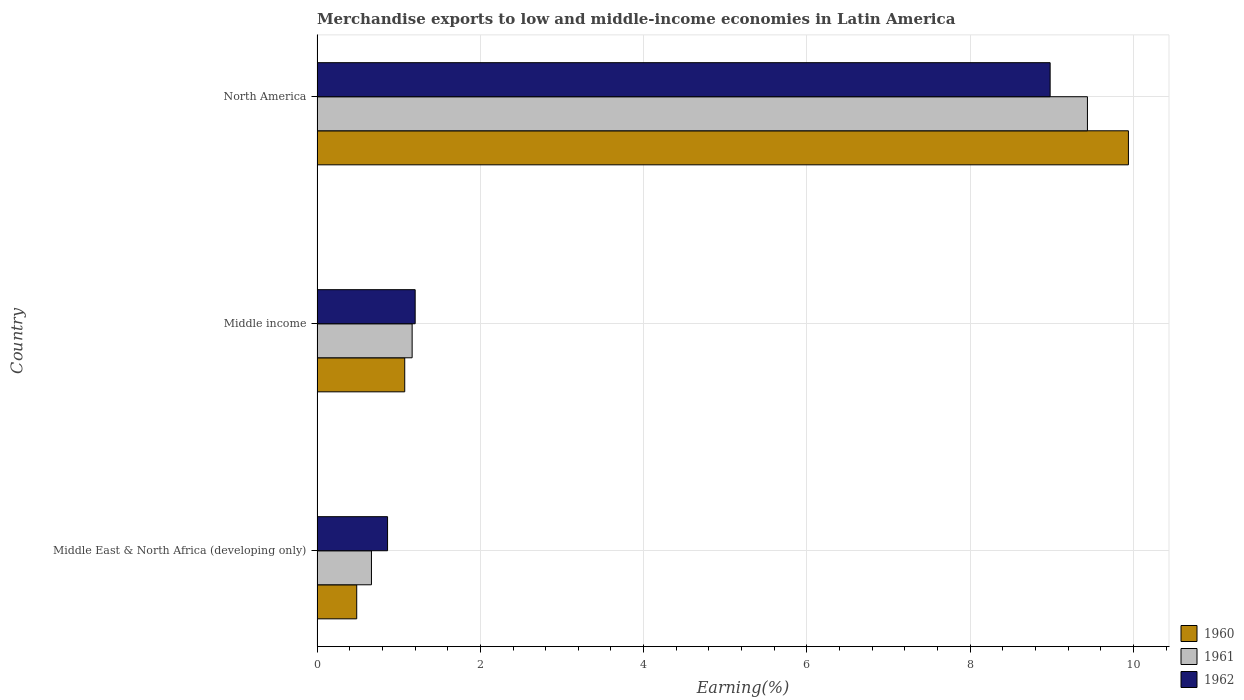How many different coloured bars are there?
Your answer should be very brief. 3. How many groups of bars are there?
Offer a terse response. 3. Are the number of bars per tick equal to the number of legend labels?
Offer a very short reply. Yes. How many bars are there on the 3rd tick from the top?
Keep it short and to the point. 3. What is the label of the 2nd group of bars from the top?
Provide a short and direct response. Middle income. What is the percentage of amount earned from merchandise exports in 1961 in Middle income?
Provide a short and direct response. 1.16. Across all countries, what is the maximum percentage of amount earned from merchandise exports in 1961?
Your answer should be compact. 9.44. Across all countries, what is the minimum percentage of amount earned from merchandise exports in 1962?
Your answer should be very brief. 0.86. In which country was the percentage of amount earned from merchandise exports in 1962 minimum?
Make the answer very short. Middle East & North Africa (developing only). What is the total percentage of amount earned from merchandise exports in 1962 in the graph?
Provide a short and direct response. 11.04. What is the difference between the percentage of amount earned from merchandise exports in 1960 in Middle income and that in North America?
Offer a very short reply. -8.86. What is the difference between the percentage of amount earned from merchandise exports in 1962 in Middle income and the percentage of amount earned from merchandise exports in 1960 in Middle East & North Africa (developing only)?
Keep it short and to the point. 0.72. What is the average percentage of amount earned from merchandise exports in 1961 per country?
Make the answer very short. 3.76. What is the difference between the percentage of amount earned from merchandise exports in 1962 and percentage of amount earned from merchandise exports in 1960 in Middle income?
Provide a succinct answer. 0.13. In how many countries, is the percentage of amount earned from merchandise exports in 1960 greater than 1.6 %?
Offer a very short reply. 1. What is the ratio of the percentage of amount earned from merchandise exports in 1961 in Middle East & North Africa (developing only) to that in Middle income?
Your answer should be compact. 0.57. Is the difference between the percentage of amount earned from merchandise exports in 1962 in Middle income and North America greater than the difference between the percentage of amount earned from merchandise exports in 1960 in Middle income and North America?
Offer a very short reply. Yes. What is the difference between the highest and the second highest percentage of amount earned from merchandise exports in 1960?
Provide a succinct answer. 8.86. What is the difference between the highest and the lowest percentage of amount earned from merchandise exports in 1960?
Make the answer very short. 9.45. What does the 2nd bar from the bottom in North America represents?
Keep it short and to the point. 1961. Is it the case that in every country, the sum of the percentage of amount earned from merchandise exports in 1961 and percentage of amount earned from merchandise exports in 1962 is greater than the percentage of amount earned from merchandise exports in 1960?
Keep it short and to the point. Yes. How many bars are there?
Provide a succinct answer. 9. Are all the bars in the graph horizontal?
Keep it short and to the point. Yes. How many countries are there in the graph?
Make the answer very short. 3. Are the values on the major ticks of X-axis written in scientific E-notation?
Keep it short and to the point. No. Does the graph contain grids?
Give a very brief answer. Yes. What is the title of the graph?
Your response must be concise. Merchandise exports to low and middle-income economies in Latin America. What is the label or title of the X-axis?
Provide a succinct answer. Earning(%). What is the label or title of the Y-axis?
Your answer should be compact. Country. What is the Earning(%) of 1960 in Middle East & North Africa (developing only)?
Ensure brevity in your answer.  0.49. What is the Earning(%) in 1961 in Middle East & North Africa (developing only)?
Offer a terse response. 0.67. What is the Earning(%) of 1962 in Middle East & North Africa (developing only)?
Keep it short and to the point. 0.86. What is the Earning(%) of 1960 in Middle income?
Ensure brevity in your answer.  1.07. What is the Earning(%) of 1961 in Middle income?
Your answer should be very brief. 1.16. What is the Earning(%) in 1962 in Middle income?
Ensure brevity in your answer.  1.2. What is the Earning(%) of 1960 in North America?
Give a very brief answer. 9.94. What is the Earning(%) in 1961 in North America?
Your answer should be compact. 9.44. What is the Earning(%) of 1962 in North America?
Make the answer very short. 8.98. Across all countries, what is the maximum Earning(%) in 1960?
Your answer should be very brief. 9.94. Across all countries, what is the maximum Earning(%) of 1961?
Your response must be concise. 9.44. Across all countries, what is the maximum Earning(%) of 1962?
Your response must be concise. 8.98. Across all countries, what is the minimum Earning(%) of 1960?
Keep it short and to the point. 0.49. Across all countries, what is the minimum Earning(%) of 1961?
Provide a succinct answer. 0.67. Across all countries, what is the minimum Earning(%) of 1962?
Provide a short and direct response. 0.86. What is the total Earning(%) in 1960 in the graph?
Give a very brief answer. 11.5. What is the total Earning(%) of 1961 in the graph?
Keep it short and to the point. 11.27. What is the total Earning(%) in 1962 in the graph?
Provide a succinct answer. 11.04. What is the difference between the Earning(%) of 1960 in Middle East & North Africa (developing only) and that in Middle income?
Keep it short and to the point. -0.59. What is the difference between the Earning(%) of 1961 in Middle East & North Africa (developing only) and that in Middle income?
Provide a succinct answer. -0.5. What is the difference between the Earning(%) of 1962 in Middle East & North Africa (developing only) and that in Middle income?
Your answer should be very brief. -0.34. What is the difference between the Earning(%) of 1960 in Middle East & North Africa (developing only) and that in North America?
Your response must be concise. -9.45. What is the difference between the Earning(%) of 1961 in Middle East & North Africa (developing only) and that in North America?
Offer a very short reply. -8.77. What is the difference between the Earning(%) of 1962 in Middle East & North Africa (developing only) and that in North America?
Give a very brief answer. -8.12. What is the difference between the Earning(%) of 1960 in Middle income and that in North America?
Keep it short and to the point. -8.86. What is the difference between the Earning(%) of 1961 in Middle income and that in North America?
Offer a very short reply. -8.27. What is the difference between the Earning(%) of 1962 in Middle income and that in North America?
Offer a very short reply. -7.78. What is the difference between the Earning(%) of 1960 in Middle East & North Africa (developing only) and the Earning(%) of 1961 in Middle income?
Your answer should be very brief. -0.68. What is the difference between the Earning(%) in 1960 in Middle East & North Africa (developing only) and the Earning(%) in 1962 in Middle income?
Provide a short and direct response. -0.72. What is the difference between the Earning(%) in 1961 in Middle East & North Africa (developing only) and the Earning(%) in 1962 in Middle income?
Offer a very short reply. -0.54. What is the difference between the Earning(%) in 1960 in Middle East & North Africa (developing only) and the Earning(%) in 1961 in North America?
Offer a very short reply. -8.95. What is the difference between the Earning(%) in 1960 in Middle East & North Africa (developing only) and the Earning(%) in 1962 in North America?
Provide a succinct answer. -8.49. What is the difference between the Earning(%) in 1961 in Middle East & North Africa (developing only) and the Earning(%) in 1962 in North America?
Your response must be concise. -8.31. What is the difference between the Earning(%) in 1960 in Middle income and the Earning(%) in 1961 in North America?
Your answer should be very brief. -8.36. What is the difference between the Earning(%) of 1960 in Middle income and the Earning(%) of 1962 in North America?
Offer a very short reply. -7.91. What is the difference between the Earning(%) of 1961 in Middle income and the Earning(%) of 1962 in North America?
Your response must be concise. -7.81. What is the average Earning(%) of 1960 per country?
Offer a terse response. 3.83. What is the average Earning(%) in 1961 per country?
Your answer should be compact. 3.76. What is the average Earning(%) in 1962 per country?
Your answer should be compact. 3.68. What is the difference between the Earning(%) in 1960 and Earning(%) in 1961 in Middle East & North Africa (developing only)?
Give a very brief answer. -0.18. What is the difference between the Earning(%) in 1960 and Earning(%) in 1962 in Middle East & North Africa (developing only)?
Keep it short and to the point. -0.38. What is the difference between the Earning(%) of 1961 and Earning(%) of 1962 in Middle East & North Africa (developing only)?
Provide a short and direct response. -0.2. What is the difference between the Earning(%) in 1960 and Earning(%) in 1961 in Middle income?
Make the answer very short. -0.09. What is the difference between the Earning(%) of 1960 and Earning(%) of 1962 in Middle income?
Ensure brevity in your answer.  -0.13. What is the difference between the Earning(%) of 1961 and Earning(%) of 1962 in Middle income?
Provide a succinct answer. -0.04. What is the difference between the Earning(%) in 1960 and Earning(%) in 1961 in North America?
Ensure brevity in your answer.  0.5. What is the difference between the Earning(%) in 1960 and Earning(%) in 1962 in North America?
Your answer should be compact. 0.96. What is the difference between the Earning(%) in 1961 and Earning(%) in 1962 in North America?
Provide a short and direct response. 0.46. What is the ratio of the Earning(%) in 1960 in Middle East & North Africa (developing only) to that in Middle income?
Provide a succinct answer. 0.45. What is the ratio of the Earning(%) in 1961 in Middle East & North Africa (developing only) to that in Middle income?
Your response must be concise. 0.57. What is the ratio of the Earning(%) in 1962 in Middle East & North Africa (developing only) to that in Middle income?
Your answer should be very brief. 0.72. What is the ratio of the Earning(%) of 1960 in Middle East & North Africa (developing only) to that in North America?
Keep it short and to the point. 0.05. What is the ratio of the Earning(%) of 1961 in Middle East & North Africa (developing only) to that in North America?
Provide a short and direct response. 0.07. What is the ratio of the Earning(%) in 1962 in Middle East & North Africa (developing only) to that in North America?
Provide a succinct answer. 0.1. What is the ratio of the Earning(%) in 1960 in Middle income to that in North America?
Give a very brief answer. 0.11. What is the ratio of the Earning(%) in 1961 in Middle income to that in North America?
Offer a terse response. 0.12. What is the ratio of the Earning(%) of 1962 in Middle income to that in North America?
Make the answer very short. 0.13. What is the difference between the highest and the second highest Earning(%) in 1960?
Ensure brevity in your answer.  8.86. What is the difference between the highest and the second highest Earning(%) of 1961?
Your response must be concise. 8.27. What is the difference between the highest and the second highest Earning(%) of 1962?
Your response must be concise. 7.78. What is the difference between the highest and the lowest Earning(%) in 1960?
Offer a terse response. 9.45. What is the difference between the highest and the lowest Earning(%) of 1961?
Give a very brief answer. 8.77. What is the difference between the highest and the lowest Earning(%) of 1962?
Offer a very short reply. 8.12. 